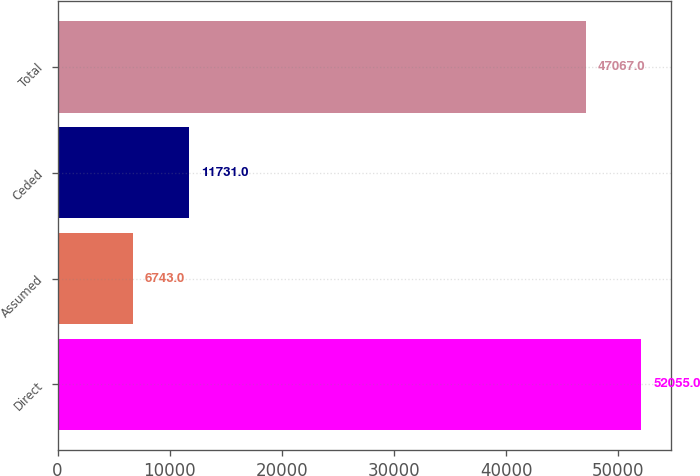<chart> <loc_0><loc_0><loc_500><loc_500><bar_chart><fcel>Direct<fcel>Assumed<fcel>Ceded<fcel>Total<nl><fcel>52055<fcel>6743<fcel>11731<fcel>47067<nl></chart> 